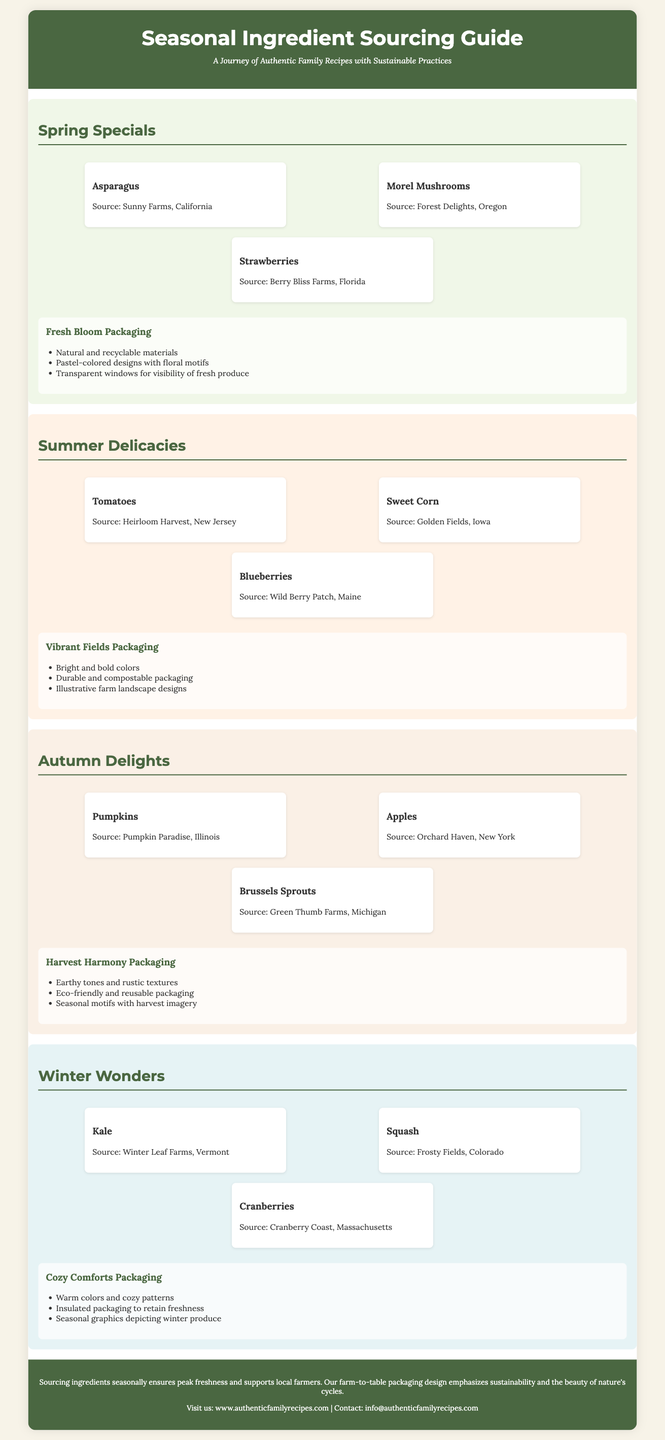what is the title of the document? The title of the document is presented prominently at the top of the page in the header section.
Answer: Seasonal Ingredient Sourcing Guide who is the source for strawberries? The source for strawberries is mentioned below the ingredient name in the first section.
Answer: Berry Bliss Farms, Florida how many seasonal sections are there in the document? The document is divided into four distinct seasonal sections, which are clearly labeled.
Answer: Four what type of packaging is used in Summer Delicacies? Each seasonal section details the type of packaging associated with the ingredients listed.
Answer: Vibrant Fields Packaging what is the primary color scheme of Fresh Bloom Packaging? The characteristics of the Fresh Bloom Packaging describe its visual appeal in the Spring Specials section.
Answer: Pastel-colored designs which ingredient is sourced from Frosty Fields? The document lists the source of different ingredients under the Winter Wonders section.
Answer: Squash how does sourcing seasonal ingredients benefit farmers? The footer summarizes the benefits of sourcing ingredients seasonally.
Answer: Supports local farmers what is the unique feature of Cozy Comforts Packaging? The features of the Cozy Comforts Packaging are mentioned in relation to its purpose for winter produce.
Answer: Insulated packaging to retain freshness 